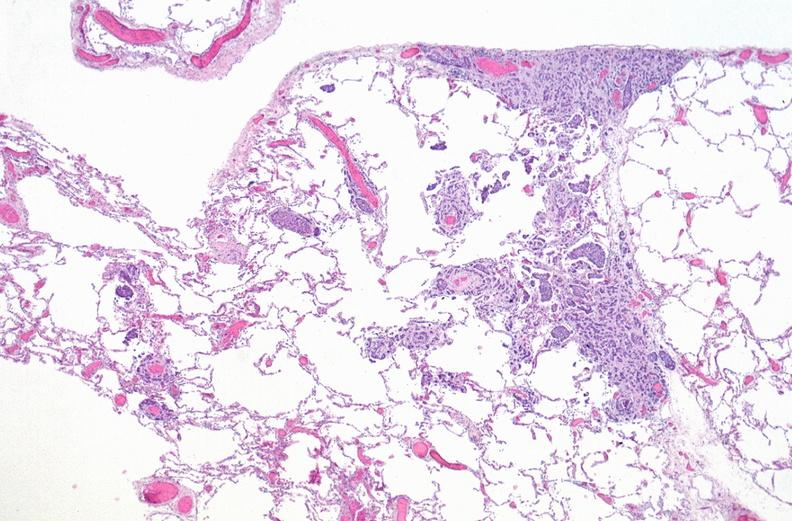s respiratory present?
Answer the question using a single word or phrase. Yes 